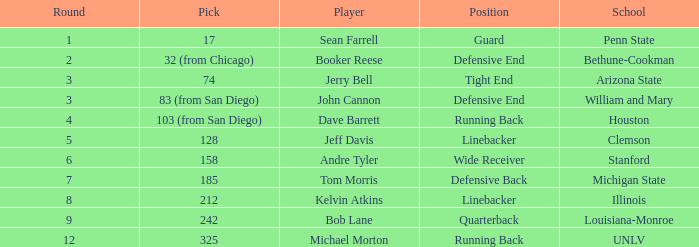Which school has a quarterback? Louisiana-Monroe. 